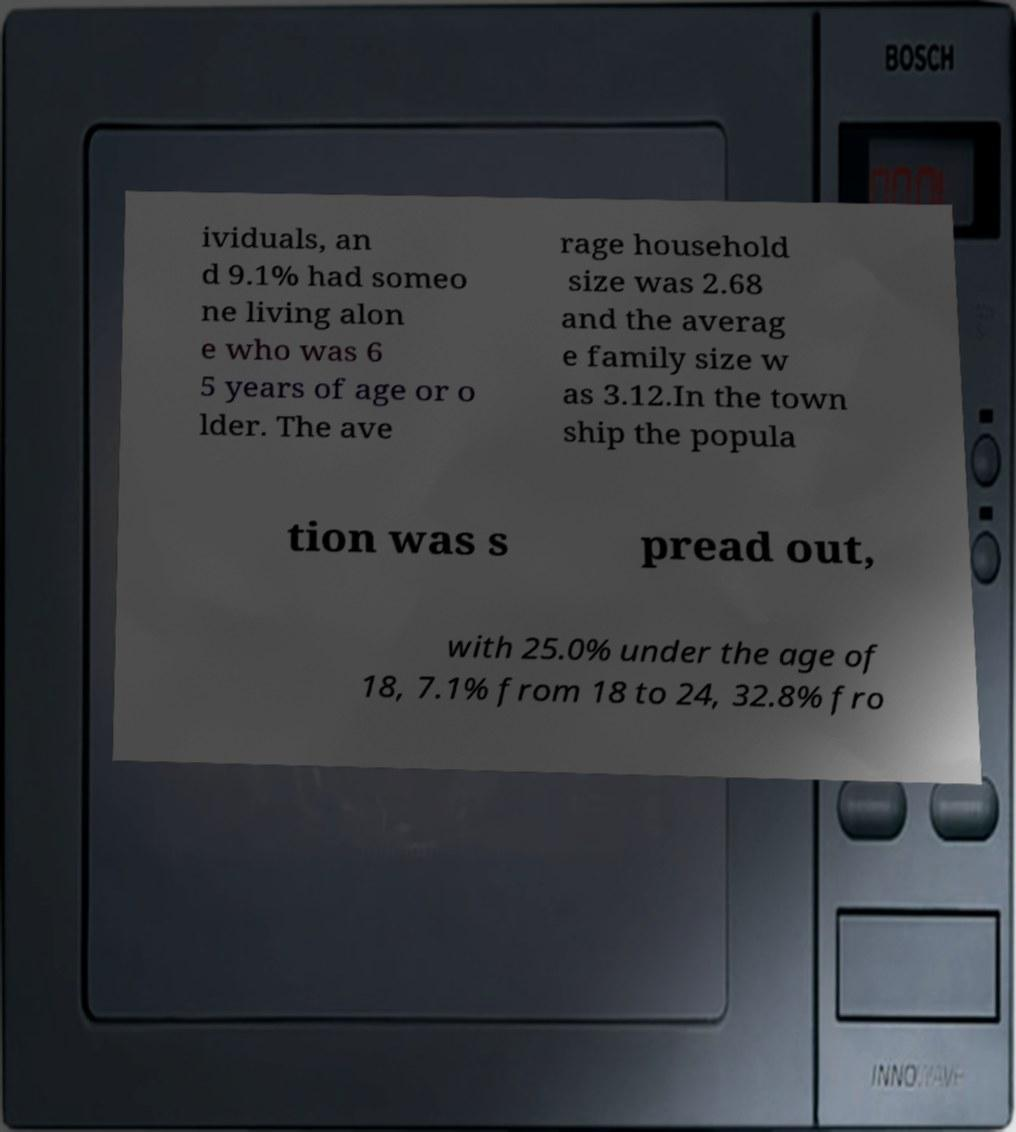I need the written content from this picture converted into text. Can you do that? ividuals, an d 9.1% had someo ne living alon e who was 6 5 years of age or o lder. The ave rage household size was 2.68 and the averag e family size w as 3.12.In the town ship the popula tion was s pread out, with 25.0% under the age of 18, 7.1% from 18 to 24, 32.8% fro 